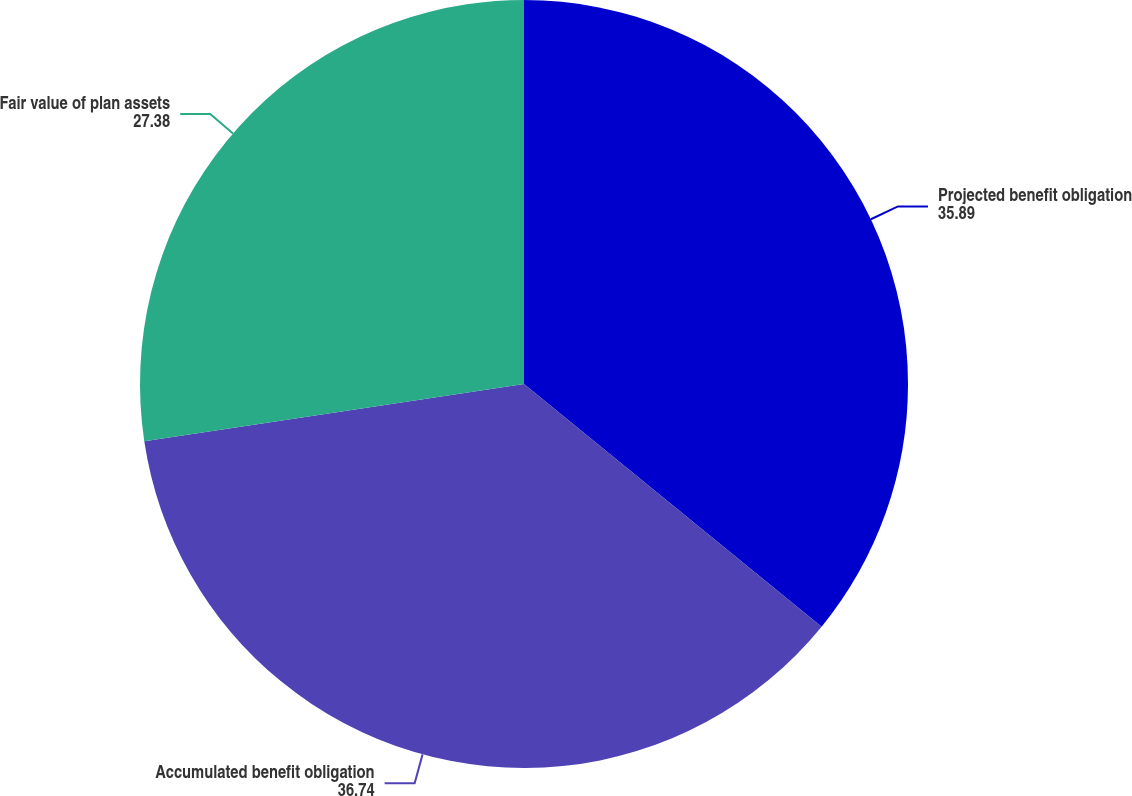Convert chart to OTSL. <chart><loc_0><loc_0><loc_500><loc_500><pie_chart><fcel>Projected benefit obligation<fcel>Accumulated benefit obligation<fcel>Fair value of plan assets<nl><fcel>35.89%<fcel>36.74%<fcel>27.38%<nl></chart> 